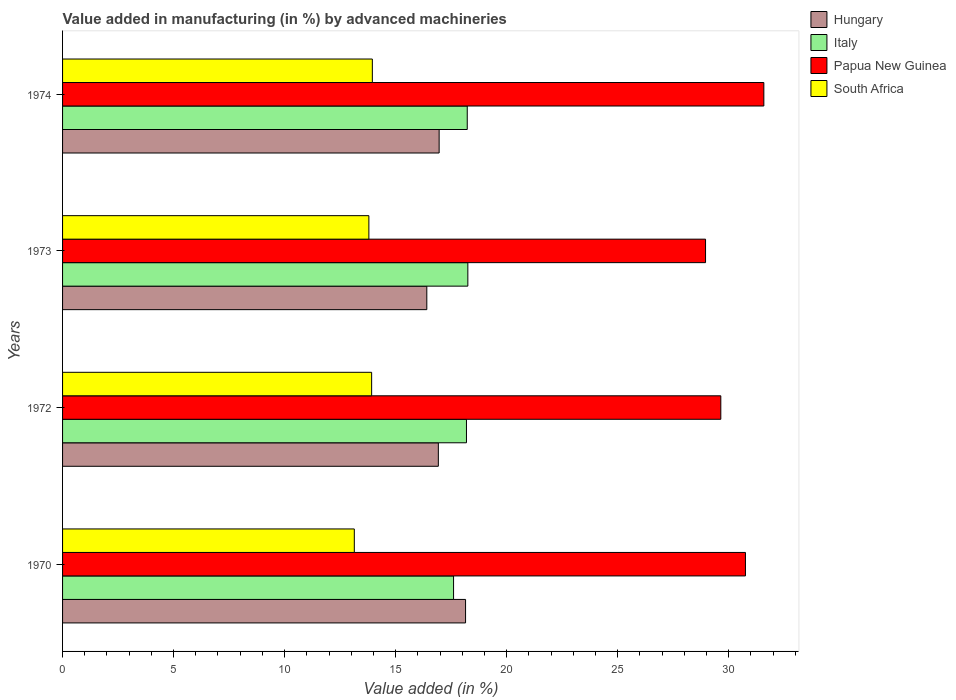How many different coloured bars are there?
Give a very brief answer. 4. How many groups of bars are there?
Your response must be concise. 4. How many bars are there on the 4th tick from the top?
Offer a very short reply. 4. How many bars are there on the 4th tick from the bottom?
Offer a terse response. 4. What is the label of the 4th group of bars from the top?
Make the answer very short. 1970. What is the percentage of value added in manufacturing by advanced machineries in Italy in 1970?
Provide a succinct answer. 17.61. Across all years, what is the maximum percentage of value added in manufacturing by advanced machineries in Papua New Guinea?
Make the answer very short. 31.59. Across all years, what is the minimum percentage of value added in manufacturing by advanced machineries in Papua New Guinea?
Your answer should be very brief. 28.96. In which year was the percentage of value added in manufacturing by advanced machineries in Papua New Guinea maximum?
Offer a very short reply. 1974. What is the total percentage of value added in manufacturing by advanced machineries in South Africa in the graph?
Offer a terse response. 54.81. What is the difference between the percentage of value added in manufacturing by advanced machineries in Italy in 1972 and that in 1974?
Your answer should be compact. -0.03. What is the difference between the percentage of value added in manufacturing by advanced machineries in Papua New Guinea in 1973 and the percentage of value added in manufacturing by advanced machineries in South Africa in 1974?
Offer a very short reply. 15.01. What is the average percentage of value added in manufacturing by advanced machineries in Papua New Guinea per year?
Your response must be concise. 30.24. In the year 1970, what is the difference between the percentage of value added in manufacturing by advanced machineries in South Africa and percentage of value added in manufacturing by advanced machineries in Italy?
Give a very brief answer. -4.47. In how many years, is the percentage of value added in manufacturing by advanced machineries in South Africa greater than 11 %?
Your response must be concise. 4. What is the ratio of the percentage of value added in manufacturing by advanced machineries in Italy in 1970 to that in 1972?
Keep it short and to the point. 0.97. Is the difference between the percentage of value added in manufacturing by advanced machineries in South Africa in 1972 and 1974 greater than the difference between the percentage of value added in manufacturing by advanced machineries in Italy in 1972 and 1974?
Keep it short and to the point. Yes. What is the difference between the highest and the second highest percentage of value added in manufacturing by advanced machineries in Hungary?
Make the answer very short. 1.19. What is the difference between the highest and the lowest percentage of value added in manufacturing by advanced machineries in South Africa?
Your answer should be very brief. 0.81. In how many years, is the percentage of value added in manufacturing by advanced machineries in Italy greater than the average percentage of value added in manufacturing by advanced machineries in Italy taken over all years?
Provide a succinct answer. 3. What does the 3rd bar from the top in 1973 represents?
Your answer should be very brief. Italy. What does the 3rd bar from the bottom in 1974 represents?
Your answer should be compact. Papua New Guinea. Is it the case that in every year, the sum of the percentage of value added in manufacturing by advanced machineries in Hungary and percentage of value added in manufacturing by advanced machineries in Papua New Guinea is greater than the percentage of value added in manufacturing by advanced machineries in Italy?
Give a very brief answer. Yes. How many bars are there?
Ensure brevity in your answer.  16. How many years are there in the graph?
Your answer should be very brief. 4. Are the values on the major ticks of X-axis written in scientific E-notation?
Keep it short and to the point. No. Does the graph contain any zero values?
Provide a short and direct response. No. Where does the legend appear in the graph?
Keep it short and to the point. Top right. How are the legend labels stacked?
Your response must be concise. Vertical. What is the title of the graph?
Provide a succinct answer. Value added in manufacturing (in %) by advanced machineries. What is the label or title of the X-axis?
Your response must be concise. Value added (in %). What is the label or title of the Y-axis?
Keep it short and to the point. Years. What is the Value added (in %) in Hungary in 1970?
Offer a terse response. 18.15. What is the Value added (in %) in Italy in 1970?
Offer a terse response. 17.61. What is the Value added (in %) of Papua New Guinea in 1970?
Ensure brevity in your answer.  30.76. What is the Value added (in %) in South Africa in 1970?
Your answer should be very brief. 13.14. What is the Value added (in %) in Hungary in 1972?
Make the answer very short. 16.93. What is the Value added (in %) in Italy in 1972?
Your answer should be very brief. 18.19. What is the Value added (in %) of Papua New Guinea in 1972?
Provide a succinct answer. 29.65. What is the Value added (in %) of South Africa in 1972?
Ensure brevity in your answer.  13.92. What is the Value added (in %) in Hungary in 1973?
Your response must be concise. 16.41. What is the Value added (in %) of Italy in 1973?
Offer a terse response. 18.25. What is the Value added (in %) of Papua New Guinea in 1973?
Make the answer very short. 28.96. What is the Value added (in %) of South Africa in 1973?
Provide a succinct answer. 13.8. What is the Value added (in %) of Hungary in 1974?
Make the answer very short. 16.96. What is the Value added (in %) in Italy in 1974?
Your response must be concise. 18.23. What is the Value added (in %) in Papua New Guinea in 1974?
Your answer should be compact. 31.59. What is the Value added (in %) in South Africa in 1974?
Make the answer very short. 13.95. Across all years, what is the maximum Value added (in %) in Hungary?
Offer a very short reply. 18.15. Across all years, what is the maximum Value added (in %) of Italy?
Keep it short and to the point. 18.25. Across all years, what is the maximum Value added (in %) of Papua New Guinea?
Provide a succinct answer. 31.59. Across all years, what is the maximum Value added (in %) in South Africa?
Your response must be concise. 13.95. Across all years, what is the minimum Value added (in %) of Hungary?
Provide a short and direct response. 16.41. Across all years, what is the minimum Value added (in %) in Italy?
Your response must be concise. 17.61. Across all years, what is the minimum Value added (in %) of Papua New Guinea?
Your answer should be very brief. 28.96. Across all years, what is the minimum Value added (in %) of South Africa?
Make the answer very short. 13.14. What is the total Value added (in %) in Hungary in the graph?
Make the answer very short. 68.44. What is the total Value added (in %) in Italy in the graph?
Your response must be concise. 72.28. What is the total Value added (in %) of Papua New Guinea in the graph?
Provide a succinct answer. 120.95. What is the total Value added (in %) in South Africa in the graph?
Your response must be concise. 54.81. What is the difference between the Value added (in %) of Hungary in 1970 and that in 1972?
Provide a short and direct response. 1.23. What is the difference between the Value added (in %) of Italy in 1970 and that in 1972?
Your answer should be compact. -0.58. What is the difference between the Value added (in %) in Papua New Guinea in 1970 and that in 1972?
Offer a terse response. 1.11. What is the difference between the Value added (in %) of South Africa in 1970 and that in 1972?
Offer a very short reply. -0.78. What is the difference between the Value added (in %) of Hungary in 1970 and that in 1973?
Your answer should be very brief. 1.75. What is the difference between the Value added (in %) in Italy in 1970 and that in 1973?
Provide a succinct answer. -0.64. What is the difference between the Value added (in %) of Papua New Guinea in 1970 and that in 1973?
Offer a terse response. 1.8. What is the difference between the Value added (in %) in South Africa in 1970 and that in 1973?
Provide a succinct answer. -0.66. What is the difference between the Value added (in %) in Hungary in 1970 and that in 1974?
Make the answer very short. 1.19. What is the difference between the Value added (in %) in Italy in 1970 and that in 1974?
Give a very brief answer. -0.62. What is the difference between the Value added (in %) in Papua New Guinea in 1970 and that in 1974?
Keep it short and to the point. -0.83. What is the difference between the Value added (in %) in South Africa in 1970 and that in 1974?
Your answer should be very brief. -0.81. What is the difference between the Value added (in %) of Hungary in 1972 and that in 1973?
Your answer should be compact. 0.52. What is the difference between the Value added (in %) in Italy in 1972 and that in 1973?
Give a very brief answer. -0.06. What is the difference between the Value added (in %) in Papua New Guinea in 1972 and that in 1973?
Ensure brevity in your answer.  0.69. What is the difference between the Value added (in %) of South Africa in 1972 and that in 1973?
Keep it short and to the point. 0.12. What is the difference between the Value added (in %) in Hungary in 1972 and that in 1974?
Ensure brevity in your answer.  -0.04. What is the difference between the Value added (in %) of Italy in 1972 and that in 1974?
Your answer should be compact. -0.03. What is the difference between the Value added (in %) of Papua New Guinea in 1972 and that in 1974?
Your answer should be very brief. -1.94. What is the difference between the Value added (in %) of South Africa in 1972 and that in 1974?
Your response must be concise. -0.03. What is the difference between the Value added (in %) of Hungary in 1973 and that in 1974?
Your answer should be compact. -0.55. What is the difference between the Value added (in %) in Italy in 1973 and that in 1974?
Keep it short and to the point. 0.03. What is the difference between the Value added (in %) of Papua New Guinea in 1973 and that in 1974?
Provide a short and direct response. -2.63. What is the difference between the Value added (in %) in South Africa in 1973 and that in 1974?
Your response must be concise. -0.16. What is the difference between the Value added (in %) of Hungary in 1970 and the Value added (in %) of Italy in 1972?
Your answer should be very brief. -0.04. What is the difference between the Value added (in %) in Hungary in 1970 and the Value added (in %) in Papua New Guinea in 1972?
Your answer should be very brief. -11.5. What is the difference between the Value added (in %) of Hungary in 1970 and the Value added (in %) of South Africa in 1972?
Make the answer very short. 4.23. What is the difference between the Value added (in %) of Italy in 1970 and the Value added (in %) of Papua New Guinea in 1972?
Your answer should be compact. -12.04. What is the difference between the Value added (in %) in Italy in 1970 and the Value added (in %) in South Africa in 1972?
Your response must be concise. 3.69. What is the difference between the Value added (in %) in Papua New Guinea in 1970 and the Value added (in %) in South Africa in 1972?
Your answer should be compact. 16.84. What is the difference between the Value added (in %) in Hungary in 1970 and the Value added (in %) in Italy in 1973?
Offer a very short reply. -0.1. What is the difference between the Value added (in %) in Hungary in 1970 and the Value added (in %) in Papua New Guinea in 1973?
Keep it short and to the point. -10.81. What is the difference between the Value added (in %) of Hungary in 1970 and the Value added (in %) of South Africa in 1973?
Offer a very short reply. 4.35. What is the difference between the Value added (in %) of Italy in 1970 and the Value added (in %) of Papua New Guinea in 1973?
Provide a short and direct response. -11.35. What is the difference between the Value added (in %) in Italy in 1970 and the Value added (in %) in South Africa in 1973?
Ensure brevity in your answer.  3.81. What is the difference between the Value added (in %) of Papua New Guinea in 1970 and the Value added (in %) of South Africa in 1973?
Your answer should be very brief. 16.96. What is the difference between the Value added (in %) in Hungary in 1970 and the Value added (in %) in Italy in 1974?
Provide a short and direct response. -0.08. What is the difference between the Value added (in %) in Hungary in 1970 and the Value added (in %) in Papua New Guinea in 1974?
Provide a succinct answer. -13.43. What is the difference between the Value added (in %) in Hungary in 1970 and the Value added (in %) in South Africa in 1974?
Give a very brief answer. 4.2. What is the difference between the Value added (in %) in Italy in 1970 and the Value added (in %) in Papua New Guinea in 1974?
Provide a succinct answer. -13.98. What is the difference between the Value added (in %) in Italy in 1970 and the Value added (in %) in South Africa in 1974?
Offer a terse response. 3.66. What is the difference between the Value added (in %) in Papua New Guinea in 1970 and the Value added (in %) in South Africa in 1974?
Your answer should be very brief. 16.8. What is the difference between the Value added (in %) of Hungary in 1972 and the Value added (in %) of Italy in 1973?
Give a very brief answer. -1.33. What is the difference between the Value added (in %) of Hungary in 1972 and the Value added (in %) of Papua New Guinea in 1973?
Your answer should be very brief. -12.04. What is the difference between the Value added (in %) in Hungary in 1972 and the Value added (in %) in South Africa in 1973?
Make the answer very short. 3.13. What is the difference between the Value added (in %) of Italy in 1972 and the Value added (in %) of Papua New Guinea in 1973?
Keep it short and to the point. -10.77. What is the difference between the Value added (in %) in Italy in 1972 and the Value added (in %) in South Africa in 1973?
Ensure brevity in your answer.  4.4. What is the difference between the Value added (in %) in Papua New Guinea in 1972 and the Value added (in %) in South Africa in 1973?
Provide a short and direct response. 15.85. What is the difference between the Value added (in %) in Hungary in 1972 and the Value added (in %) in Italy in 1974?
Keep it short and to the point. -1.3. What is the difference between the Value added (in %) of Hungary in 1972 and the Value added (in %) of Papua New Guinea in 1974?
Make the answer very short. -14.66. What is the difference between the Value added (in %) of Hungary in 1972 and the Value added (in %) of South Africa in 1974?
Keep it short and to the point. 2.97. What is the difference between the Value added (in %) in Italy in 1972 and the Value added (in %) in Papua New Guinea in 1974?
Your response must be concise. -13.39. What is the difference between the Value added (in %) of Italy in 1972 and the Value added (in %) of South Africa in 1974?
Your answer should be compact. 4.24. What is the difference between the Value added (in %) in Papua New Guinea in 1972 and the Value added (in %) in South Africa in 1974?
Your response must be concise. 15.7. What is the difference between the Value added (in %) of Hungary in 1973 and the Value added (in %) of Italy in 1974?
Your response must be concise. -1.82. What is the difference between the Value added (in %) of Hungary in 1973 and the Value added (in %) of Papua New Guinea in 1974?
Your answer should be compact. -15.18. What is the difference between the Value added (in %) of Hungary in 1973 and the Value added (in %) of South Africa in 1974?
Offer a terse response. 2.45. What is the difference between the Value added (in %) in Italy in 1973 and the Value added (in %) in Papua New Guinea in 1974?
Your answer should be compact. -13.33. What is the difference between the Value added (in %) in Italy in 1973 and the Value added (in %) in South Africa in 1974?
Your response must be concise. 4.3. What is the difference between the Value added (in %) in Papua New Guinea in 1973 and the Value added (in %) in South Africa in 1974?
Provide a succinct answer. 15.01. What is the average Value added (in %) in Hungary per year?
Provide a succinct answer. 17.11. What is the average Value added (in %) of Italy per year?
Ensure brevity in your answer.  18.07. What is the average Value added (in %) of Papua New Guinea per year?
Provide a short and direct response. 30.24. What is the average Value added (in %) in South Africa per year?
Your answer should be compact. 13.7. In the year 1970, what is the difference between the Value added (in %) of Hungary and Value added (in %) of Italy?
Your answer should be compact. 0.54. In the year 1970, what is the difference between the Value added (in %) of Hungary and Value added (in %) of Papua New Guinea?
Your answer should be very brief. -12.61. In the year 1970, what is the difference between the Value added (in %) in Hungary and Value added (in %) in South Africa?
Ensure brevity in your answer.  5.01. In the year 1970, what is the difference between the Value added (in %) of Italy and Value added (in %) of Papua New Guinea?
Give a very brief answer. -13.15. In the year 1970, what is the difference between the Value added (in %) in Italy and Value added (in %) in South Africa?
Give a very brief answer. 4.47. In the year 1970, what is the difference between the Value added (in %) in Papua New Guinea and Value added (in %) in South Africa?
Provide a succinct answer. 17.62. In the year 1972, what is the difference between the Value added (in %) of Hungary and Value added (in %) of Italy?
Ensure brevity in your answer.  -1.27. In the year 1972, what is the difference between the Value added (in %) of Hungary and Value added (in %) of Papua New Guinea?
Ensure brevity in your answer.  -12.72. In the year 1972, what is the difference between the Value added (in %) in Hungary and Value added (in %) in South Africa?
Ensure brevity in your answer.  3. In the year 1972, what is the difference between the Value added (in %) in Italy and Value added (in %) in Papua New Guinea?
Provide a succinct answer. -11.46. In the year 1972, what is the difference between the Value added (in %) in Italy and Value added (in %) in South Africa?
Give a very brief answer. 4.27. In the year 1972, what is the difference between the Value added (in %) of Papua New Guinea and Value added (in %) of South Africa?
Provide a short and direct response. 15.73. In the year 1973, what is the difference between the Value added (in %) in Hungary and Value added (in %) in Italy?
Offer a terse response. -1.85. In the year 1973, what is the difference between the Value added (in %) in Hungary and Value added (in %) in Papua New Guinea?
Provide a succinct answer. -12.55. In the year 1973, what is the difference between the Value added (in %) in Hungary and Value added (in %) in South Africa?
Keep it short and to the point. 2.61. In the year 1973, what is the difference between the Value added (in %) in Italy and Value added (in %) in Papua New Guinea?
Offer a terse response. -10.71. In the year 1973, what is the difference between the Value added (in %) of Italy and Value added (in %) of South Africa?
Provide a succinct answer. 4.46. In the year 1973, what is the difference between the Value added (in %) of Papua New Guinea and Value added (in %) of South Africa?
Your answer should be compact. 15.16. In the year 1974, what is the difference between the Value added (in %) of Hungary and Value added (in %) of Italy?
Your answer should be very brief. -1.27. In the year 1974, what is the difference between the Value added (in %) in Hungary and Value added (in %) in Papua New Guinea?
Your answer should be compact. -14.63. In the year 1974, what is the difference between the Value added (in %) of Hungary and Value added (in %) of South Africa?
Offer a very short reply. 3.01. In the year 1974, what is the difference between the Value added (in %) in Italy and Value added (in %) in Papua New Guinea?
Your answer should be very brief. -13.36. In the year 1974, what is the difference between the Value added (in %) in Italy and Value added (in %) in South Africa?
Your response must be concise. 4.27. In the year 1974, what is the difference between the Value added (in %) in Papua New Guinea and Value added (in %) in South Africa?
Your response must be concise. 17.63. What is the ratio of the Value added (in %) in Hungary in 1970 to that in 1972?
Your answer should be very brief. 1.07. What is the ratio of the Value added (in %) in Italy in 1970 to that in 1972?
Your response must be concise. 0.97. What is the ratio of the Value added (in %) in Papua New Guinea in 1970 to that in 1972?
Your answer should be compact. 1.04. What is the ratio of the Value added (in %) in South Africa in 1970 to that in 1972?
Ensure brevity in your answer.  0.94. What is the ratio of the Value added (in %) of Hungary in 1970 to that in 1973?
Your answer should be very brief. 1.11. What is the ratio of the Value added (in %) of Italy in 1970 to that in 1973?
Your answer should be very brief. 0.96. What is the ratio of the Value added (in %) of Papua New Guinea in 1970 to that in 1973?
Provide a succinct answer. 1.06. What is the ratio of the Value added (in %) in South Africa in 1970 to that in 1973?
Make the answer very short. 0.95. What is the ratio of the Value added (in %) of Hungary in 1970 to that in 1974?
Offer a terse response. 1.07. What is the ratio of the Value added (in %) in Italy in 1970 to that in 1974?
Your answer should be compact. 0.97. What is the ratio of the Value added (in %) of Papua New Guinea in 1970 to that in 1974?
Keep it short and to the point. 0.97. What is the ratio of the Value added (in %) of South Africa in 1970 to that in 1974?
Your answer should be compact. 0.94. What is the ratio of the Value added (in %) in Hungary in 1972 to that in 1973?
Ensure brevity in your answer.  1.03. What is the ratio of the Value added (in %) in Papua New Guinea in 1972 to that in 1973?
Provide a short and direct response. 1.02. What is the ratio of the Value added (in %) in Papua New Guinea in 1972 to that in 1974?
Your answer should be very brief. 0.94. What is the ratio of the Value added (in %) in South Africa in 1972 to that in 1974?
Offer a terse response. 1. What is the ratio of the Value added (in %) of Hungary in 1973 to that in 1974?
Ensure brevity in your answer.  0.97. What is the ratio of the Value added (in %) in Italy in 1973 to that in 1974?
Provide a succinct answer. 1. What is the ratio of the Value added (in %) of Papua New Guinea in 1973 to that in 1974?
Keep it short and to the point. 0.92. What is the ratio of the Value added (in %) in South Africa in 1973 to that in 1974?
Your answer should be very brief. 0.99. What is the difference between the highest and the second highest Value added (in %) of Hungary?
Your response must be concise. 1.19. What is the difference between the highest and the second highest Value added (in %) in Italy?
Your answer should be compact. 0.03. What is the difference between the highest and the second highest Value added (in %) in Papua New Guinea?
Ensure brevity in your answer.  0.83. What is the difference between the highest and the second highest Value added (in %) of South Africa?
Make the answer very short. 0.03. What is the difference between the highest and the lowest Value added (in %) in Hungary?
Give a very brief answer. 1.75. What is the difference between the highest and the lowest Value added (in %) of Italy?
Give a very brief answer. 0.64. What is the difference between the highest and the lowest Value added (in %) in Papua New Guinea?
Make the answer very short. 2.63. What is the difference between the highest and the lowest Value added (in %) of South Africa?
Offer a terse response. 0.81. 